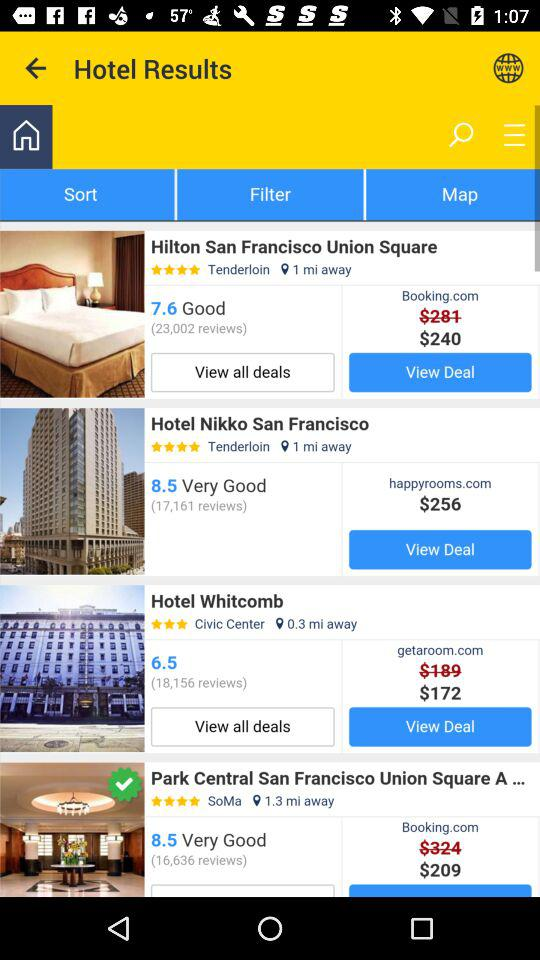What is the cost of the hotel Nikko San Francisco? The cost of the hotel, Nikko San Francisco, is $256. 